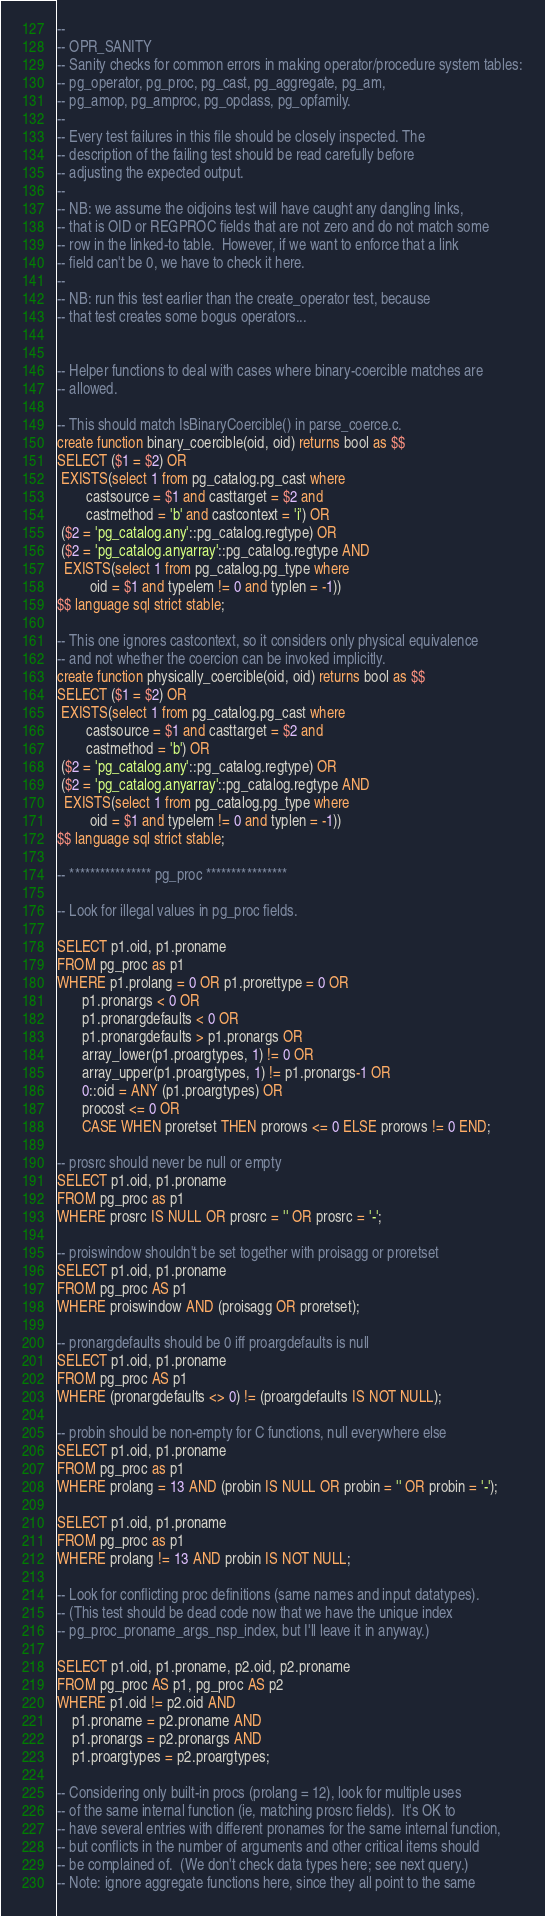<code> <loc_0><loc_0><loc_500><loc_500><_SQL_>--
-- OPR_SANITY
-- Sanity checks for common errors in making operator/procedure system tables:
-- pg_operator, pg_proc, pg_cast, pg_aggregate, pg_am,
-- pg_amop, pg_amproc, pg_opclass, pg_opfamily.
--
-- Every test failures in this file should be closely inspected. The
-- description of the failing test should be read carefully before
-- adjusting the expected output.
--
-- NB: we assume the oidjoins test will have caught any dangling links,
-- that is OID or REGPROC fields that are not zero and do not match some
-- row in the linked-to table.  However, if we want to enforce that a link
-- field can't be 0, we have to check it here.
--
-- NB: run this test earlier than the create_operator test, because
-- that test creates some bogus operators...


-- Helper functions to deal with cases where binary-coercible matches are
-- allowed.

-- This should match IsBinaryCoercible() in parse_coerce.c.
create function binary_coercible(oid, oid) returns bool as $$
SELECT ($1 = $2) OR
 EXISTS(select 1 from pg_catalog.pg_cast where
        castsource = $1 and casttarget = $2 and
        castmethod = 'b' and castcontext = 'i') OR
 ($2 = 'pg_catalog.any'::pg_catalog.regtype) OR
 ($2 = 'pg_catalog.anyarray'::pg_catalog.regtype AND
  EXISTS(select 1 from pg_catalog.pg_type where
         oid = $1 and typelem != 0 and typlen = -1))
$$ language sql strict stable;

-- This one ignores castcontext, so it considers only physical equivalence
-- and not whether the coercion can be invoked implicitly.
create function physically_coercible(oid, oid) returns bool as $$
SELECT ($1 = $2) OR
 EXISTS(select 1 from pg_catalog.pg_cast where
        castsource = $1 and casttarget = $2 and
        castmethod = 'b') OR
 ($2 = 'pg_catalog.any'::pg_catalog.regtype) OR
 ($2 = 'pg_catalog.anyarray'::pg_catalog.regtype AND
  EXISTS(select 1 from pg_catalog.pg_type where
         oid = $1 and typelem != 0 and typlen = -1))
$$ language sql strict stable;

-- **************** pg_proc ****************

-- Look for illegal values in pg_proc fields.

SELECT p1.oid, p1.proname
FROM pg_proc as p1
WHERE p1.prolang = 0 OR p1.prorettype = 0 OR
       p1.pronargs < 0 OR
       p1.pronargdefaults < 0 OR
       p1.pronargdefaults > p1.pronargs OR
       array_lower(p1.proargtypes, 1) != 0 OR
       array_upper(p1.proargtypes, 1) != p1.pronargs-1 OR
       0::oid = ANY (p1.proargtypes) OR
       procost <= 0 OR
       CASE WHEN proretset THEN prorows <= 0 ELSE prorows != 0 END;

-- prosrc should never be null or empty
SELECT p1.oid, p1.proname
FROM pg_proc as p1
WHERE prosrc IS NULL OR prosrc = '' OR prosrc = '-';

-- proiswindow shouldn't be set together with proisagg or proretset
SELECT p1.oid, p1.proname
FROM pg_proc AS p1
WHERE proiswindow AND (proisagg OR proretset);

-- pronargdefaults should be 0 iff proargdefaults is null
SELECT p1.oid, p1.proname
FROM pg_proc AS p1
WHERE (pronargdefaults <> 0) != (proargdefaults IS NOT NULL);

-- probin should be non-empty for C functions, null everywhere else
SELECT p1.oid, p1.proname
FROM pg_proc as p1
WHERE prolang = 13 AND (probin IS NULL OR probin = '' OR probin = '-');

SELECT p1.oid, p1.proname
FROM pg_proc as p1
WHERE prolang != 13 AND probin IS NOT NULL;

-- Look for conflicting proc definitions (same names and input datatypes).
-- (This test should be dead code now that we have the unique index
-- pg_proc_proname_args_nsp_index, but I'll leave it in anyway.)

SELECT p1.oid, p1.proname, p2.oid, p2.proname
FROM pg_proc AS p1, pg_proc AS p2
WHERE p1.oid != p2.oid AND
    p1.proname = p2.proname AND
    p1.pronargs = p2.pronargs AND
    p1.proargtypes = p2.proargtypes;

-- Considering only built-in procs (prolang = 12), look for multiple uses
-- of the same internal function (ie, matching prosrc fields).  It's OK to
-- have several entries with different pronames for the same internal function,
-- but conflicts in the number of arguments and other critical items should
-- be complained of.  (We don't check data types here; see next query.)
-- Note: ignore aggregate functions here, since they all point to the same</code> 